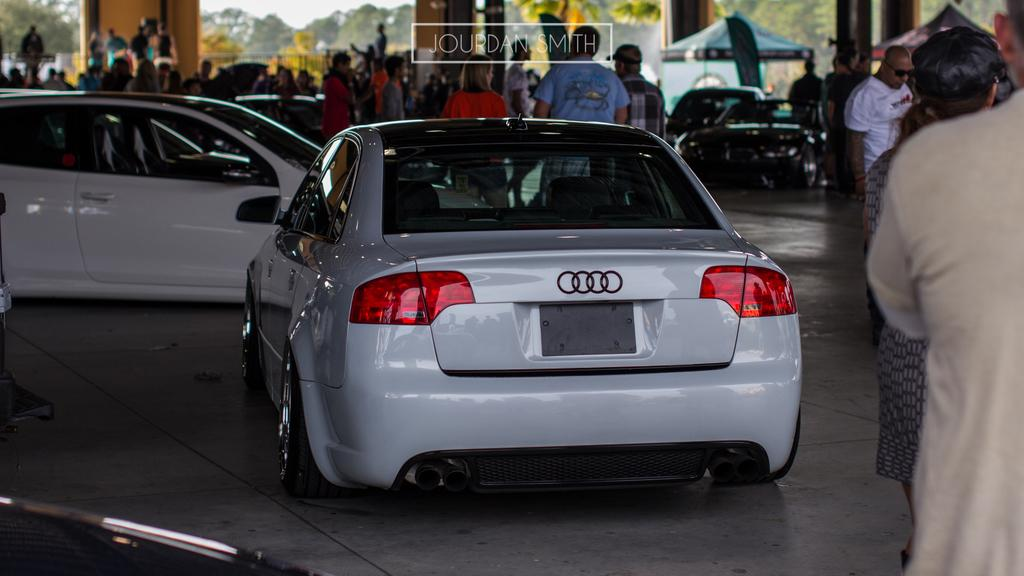What can be seen in the image in terms of transportation? There are many vehicles in the image. What else is present in the image besides vehicles? There are people on the ground, pillars, tents, and trees visible in the image. Can you describe the setting of the image? The image appears to depict a gathering or event, with vehicles, people, and tents present. What scientific experiments are being conducted in the image? There is no indication of any scientific experiments being conducted in the image. How many babies are visible in the image? There are no babies present in the image. 